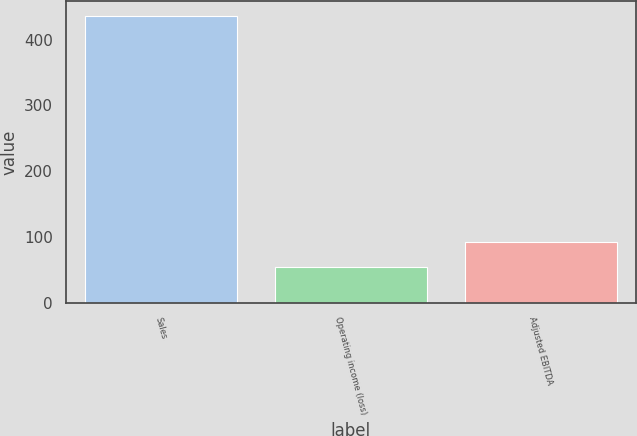Convert chart. <chart><loc_0><loc_0><loc_500><loc_500><bar_chart><fcel>Sales<fcel>Operating income (loss)<fcel>Adjusted EBITDA<nl><fcel>436.1<fcel>53.9<fcel>92.12<nl></chart> 